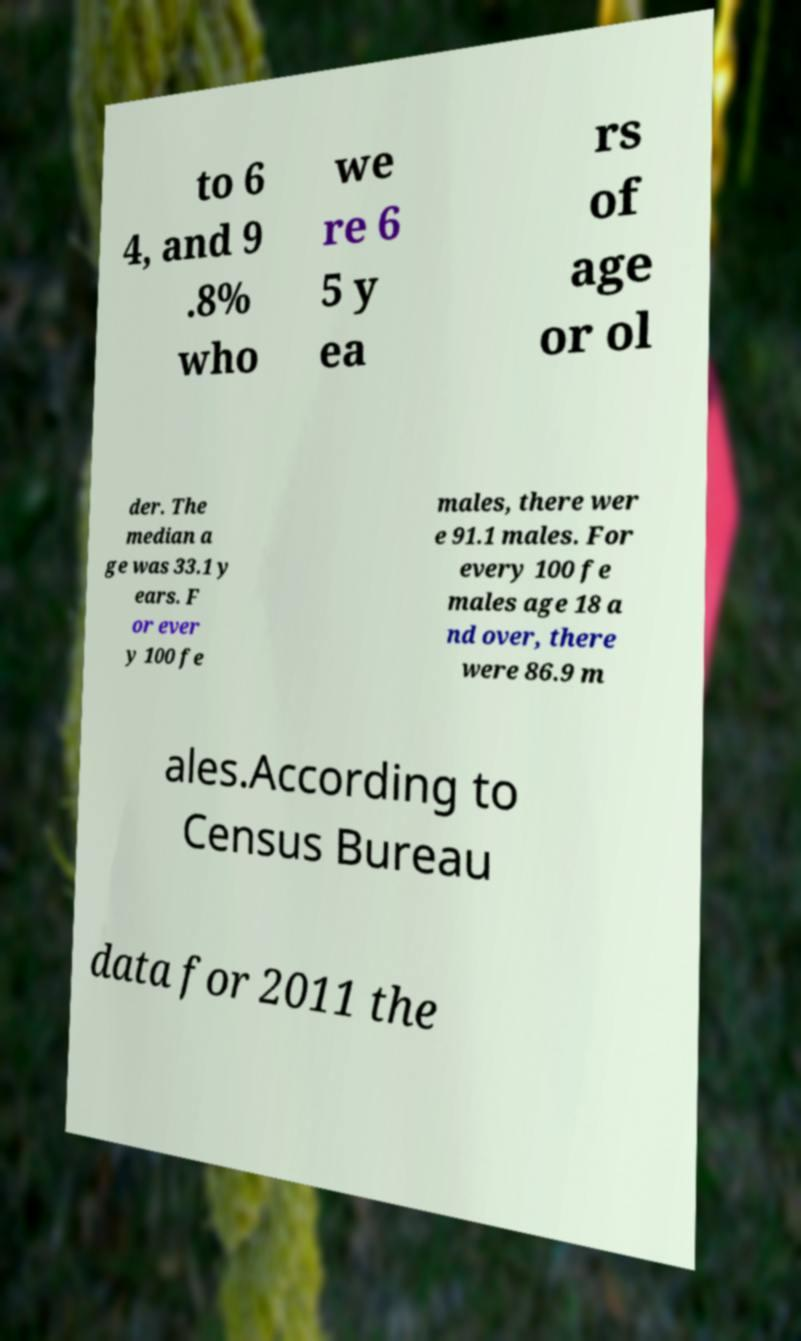Can you accurately transcribe the text from the provided image for me? to 6 4, and 9 .8% who we re 6 5 y ea rs of age or ol der. The median a ge was 33.1 y ears. F or ever y 100 fe males, there wer e 91.1 males. For every 100 fe males age 18 a nd over, there were 86.9 m ales.According to Census Bureau data for 2011 the 